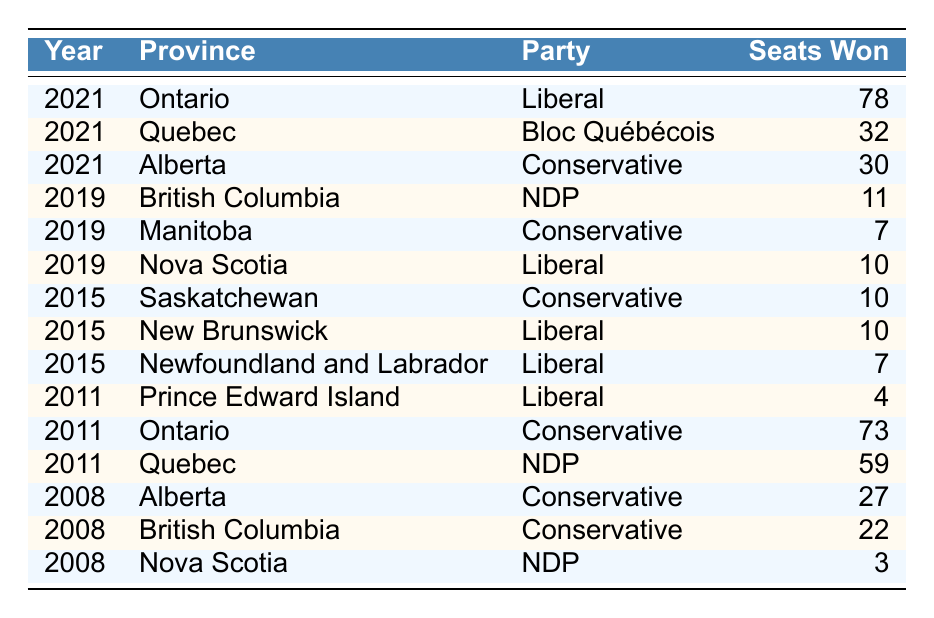What party won the most seats in Ontario in 2021? The table shows that in 2021, the Liberal party won 78 seats in Ontario, which is the highest number compared to any other party in the same province and year.
Answer: Liberal How many seats did the NDP win in British Columbia in 2019? Referring to the table, in 2019, the NDP won 11 seats in British Columbia, as directly stated in the data.
Answer: 11 Which party had the lowest number of seats in Nova Scotia across the years presented? In the table, the NDP won 3 seats in Nova Scotia in 2008, which is the lowest number of seats compared to the other years and parties listed.
Answer: NDP What is the total number of seats won by the Conservative party in Alberta from 2008 to 2021? The table indicates that the Conservative party won 30 seats in 2021 and 27 seats in 2008. Adding these together gives a total of 30 + 27 = 57 seats won by the Conservatives in Alberta over those two elections.
Answer: 57 Did the Liberal party win any seats in Saskatchewan from the data provided? Looking at the table, there are no entries for the Liberal party winning seats in Saskatchewan, making the statement false.
Answer: No What was the average number of seats won by the Liberal party in New Brunswick and Newfoundland and Labrador in 2015? The table shows that the Liberal party won 10 seats in New Brunswick and 7 seats in Newfoundland and Labrador in 2015. Adding these gives 10 + 7 = 17, and the average (17/2) = 8.5.
Answer: 8.5 Which province had the highest number of seats won by the NDP in 2011? The data shows that in 2011, Quebec had the highest seats won by the NDP with 59 seats, compared to other provinces.
Answer: Quebec Was there any province where the Conservative party won more seats than the Liberal party in 2015? Looking closely at the table, in 2015, the Conservative party won 10 seats in Saskatchewan, while the Liberal party won 10 seats in both New Brunswick and Newfoundland and Labrador; thus, there is no province where the Conservative party had more seats than the Liberal party.
Answer: No In which election year did the Bloc Québécois win seats, and how many? The table specifies that the Bloc Québécois won 32 seats in Quebec during the 2021 election year.
Answer: 2021, 32 How many seats were won by the Conservative party in Ontario in 2011 compared to the Liberal party in the same year? In 2011, the Conservative party won 73 seats, while the Liberal party did not win any seats in Ontario in that year based on the table data, which shows the Conservative party winning much more. The difference is 73 seats for Conservatives compared to 0 for Liberals.
Answer: 73 seats (Conservative) vs 0 (Liberal) 